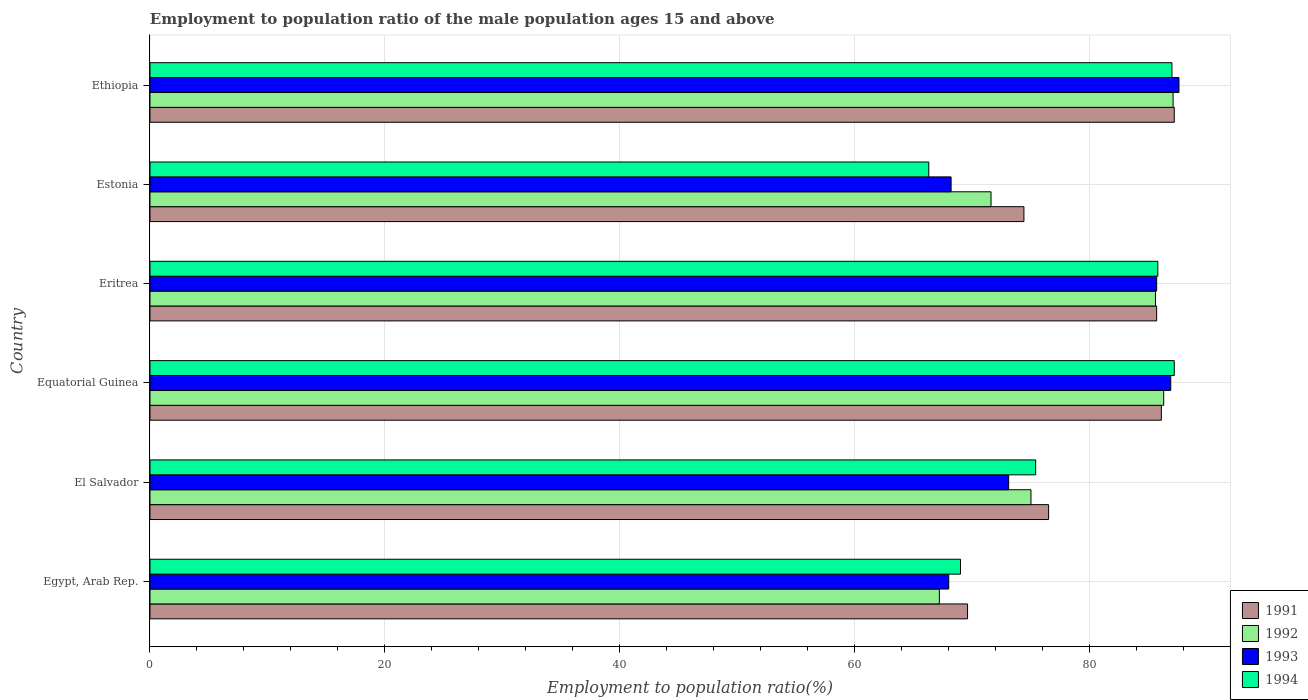How many different coloured bars are there?
Give a very brief answer. 4. How many groups of bars are there?
Your answer should be very brief. 6. Are the number of bars per tick equal to the number of legend labels?
Ensure brevity in your answer.  Yes. Are the number of bars on each tick of the Y-axis equal?
Your response must be concise. Yes. How many bars are there on the 4th tick from the top?
Provide a short and direct response. 4. What is the label of the 6th group of bars from the top?
Your answer should be compact. Egypt, Arab Rep. In how many cases, is the number of bars for a given country not equal to the number of legend labels?
Ensure brevity in your answer.  0. Across all countries, what is the maximum employment to population ratio in 1993?
Offer a terse response. 87.6. Across all countries, what is the minimum employment to population ratio in 1991?
Keep it short and to the point. 69.6. In which country was the employment to population ratio in 1992 maximum?
Provide a short and direct response. Ethiopia. In which country was the employment to population ratio in 1991 minimum?
Make the answer very short. Egypt, Arab Rep. What is the total employment to population ratio in 1994 in the graph?
Give a very brief answer. 470.7. What is the difference between the employment to population ratio in 1991 in Egypt, Arab Rep. and that in El Salvador?
Offer a terse response. -6.9. What is the difference between the employment to population ratio in 1994 in Egypt, Arab Rep. and the employment to population ratio in 1992 in El Salvador?
Your answer should be compact. -6. What is the average employment to population ratio in 1991 per country?
Keep it short and to the point. 79.92. What is the difference between the employment to population ratio in 1991 and employment to population ratio in 1992 in El Salvador?
Your response must be concise. 1.5. In how many countries, is the employment to population ratio in 1992 greater than 48 %?
Keep it short and to the point. 6. What is the ratio of the employment to population ratio in 1993 in Egypt, Arab Rep. to that in Eritrea?
Make the answer very short. 0.79. Is the difference between the employment to population ratio in 1991 in Equatorial Guinea and Estonia greater than the difference between the employment to population ratio in 1992 in Equatorial Guinea and Estonia?
Your answer should be very brief. No. What is the difference between the highest and the second highest employment to population ratio in 1992?
Make the answer very short. 0.8. What is the difference between the highest and the lowest employment to population ratio in 1992?
Provide a succinct answer. 19.9. Is the sum of the employment to population ratio in 1992 in Equatorial Guinea and Estonia greater than the maximum employment to population ratio in 1993 across all countries?
Offer a very short reply. Yes. What does the 4th bar from the bottom in El Salvador represents?
Make the answer very short. 1994. Is it the case that in every country, the sum of the employment to population ratio in 1991 and employment to population ratio in 1994 is greater than the employment to population ratio in 1993?
Give a very brief answer. Yes. Are all the bars in the graph horizontal?
Your response must be concise. Yes. What is the difference between two consecutive major ticks on the X-axis?
Offer a very short reply. 20. Does the graph contain any zero values?
Your answer should be compact. No. What is the title of the graph?
Provide a short and direct response. Employment to population ratio of the male population ages 15 and above. Does "1979" appear as one of the legend labels in the graph?
Your answer should be compact. No. What is the Employment to population ratio(%) in 1991 in Egypt, Arab Rep.?
Your answer should be very brief. 69.6. What is the Employment to population ratio(%) of 1992 in Egypt, Arab Rep.?
Your answer should be very brief. 67.2. What is the Employment to population ratio(%) of 1994 in Egypt, Arab Rep.?
Your answer should be very brief. 69. What is the Employment to population ratio(%) in 1991 in El Salvador?
Offer a terse response. 76.5. What is the Employment to population ratio(%) in 1992 in El Salvador?
Your answer should be compact. 75. What is the Employment to population ratio(%) in 1993 in El Salvador?
Provide a succinct answer. 73.1. What is the Employment to population ratio(%) of 1994 in El Salvador?
Make the answer very short. 75.4. What is the Employment to population ratio(%) of 1991 in Equatorial Guinea?
Keep it short and to the point. 86.1. What is the Employment to population ratio(%) in 1992 in Equatorial Guinea?
Your answer should be very brief. 86.3. What is the Employment to population ratio(%) of 1993 in Equatorial Guinea?
Offer a very short reply. 86.9. What is the Employment to population ratio(%) of 1994 in Equatorial Guinea?
Ensure brevity in your answer.  87.2. What is the Employment to population ratio(%) in 1991 in Eritrea?
Provide a short and direct response. 85.7. What is the Employment to population ratio(%) of 1992 in Eritrea?
Keep it short and to the point. 85.6. What is the Employment to population ratio(%) in 1993 in Eritrea?
Your answer should be compact. 85.7. What is the Employment to population ratio(%) of 1994 in Eritrea?
Offer a very short reply. 85.8. What is the Employment to population ratio(%) in 1991 in Estonia?
Ensure brevity in your answer.  74.4. What is the Employment to population ratio(%) of 1992 in Estonia?
Your response must be concise. 71.6. What is the Employment to population ratio(%) in 1993 in Estonia?
Ensure brevity in your answer.  68.2. What is the Employment to population ratio(%) of 1994 in Estonia?
Your answer should be very brief. 66.3. What is the Employment to population ratio(%) of 1991 in Ethiopia?
Your response must be concise. 87.2. What is the Employment to population ratio(%) of 1992 in Ethiopia?
Ensure brevity in your answer.  87.1. What is the Employment to population ratio(%) in 1993 in Ethiopia?
Your answer should be compact. 87.6. Across all countries, what is the maximum Employment to population ratio(%) in 1991?
Ensure brevity in your answer.  87.2. Across all countries, what is the maximum Employment to population ratio(%) in 1992?
Provide a short and direct response. 87.1. Across all countries, what is the maximum Employment to population ratio(%) in 1993?
Keep it short and to the point. 87.6. Across all countries, what is the maximum Employment to population ratio(%) in 1994?
Your answer should be very brief. 87.2. Across all countries, what is the minimum Employment to population ratio(%) in 1991?
Keep it short and to the point. 69.6. Across all countries, what is the minimum Employment to population ratio(%) of 1992?
Provide a short and direct response. 67.2. Across all countries, what is the minimum Employment to population ratio(%) in 1994?
Provide a succinct answer. 66.3. What is the total Employment to population ratio(%) of 1991 in the graph?
Ensure brevity in your answer.  479.5. What is the total Employment to population ratio(%) of 1992 in the graph?
Offer a terse response. 472.8. What is the total Employment to population ratio(%) of 1993 in the graph?
Your response must be concise. 469.5. What is the total Employment to population ratio(%) in 1994 in the graph?
Provide a short and direct response. 470.7. What is the difference between the Employment to population ratio(%) in 1991 in Egypt, Arab Rep. and that in El Salvador?
Ensure brevity in your answer.  -6.9. What is the difference between the Employment to population ratio(%) of 1992 in Egypt, Arab Rep. and that in El Salvador?
Provide a succinct answer. -7.8. What is the difference between the Employment to population ratio(%) of 1994 in Egypt, Arab Rep. and that in El Salvador?
Provide a short and direct response. -6.4. What is the difference between the Employment to population ratio(%) in 1991 in Egypt, Arab Rep. and that in Equatorial Guinea?
Ensure brevity in your answer.  -16.5. What is the difference between the Employment to population ratio(%) of 1992 in Egypt, Arab Rep. and that in Equatorial Guinea?
Your answer should be very brief. -19.1. What is the difference between the Employment to population ratio(%) in 1993 in Egypt, Arab Rep. and that in Equatorial Guinea?
Ensure brevity in your answer.  -18.9. What is the difference between the Employment to population ratio(%) in 1994 in Egypt, Arab Rep. and that in Equatorial Guinea?
Provide a short and direct response. -18.2. What is the difference between the Employment to population ratio(%) in 1991 in Egypt, Arab Rep. and that in Eritrea?
Give a very brief answer. -16.1. What is the difference between the Employment to population ratio(%) of 1992 in Egypt, Arab Rep. and that in Eritrea?
Offer a terse response. -18.4. What is the difference between the Employment to population ratio(%) of 1993 in Egypt, Arab Rep. and that in Eritrea?
Your answer should be compact. -17.7. What is the difference between the Employment to population ratio(%) of 1994 in Egypt, Arab Rep. and that in Eritrea?
Provide a succinct answer. -16.8. What is the difference between the Employment to population ratio(%) in 1991 in Egypt, Arab Rep. and that in Estonia?
Keep it short and to the point. -4.8. What is the difference between the Employment to population ratio(%) in 1992 in Egypt, Arab Rep. and that in Estonia?
Offer a very short reply. -4.4. What is the difference between the Employment to population ratio(%) of 1993 in Egypt, Arab Rep. and that in Estonia?
Offer a very short reply. -0.2. What is the difference between the Employment to population ratio(%) in 1991 in Egypt, Arab Rep. and that in Ethiopia?
Provide a short and direct response. -17.6. What is the difference between the Employment to population ratio(%) in 1992 in Egypt, Arab Rep. and that in Ethiopia?
Your answer should be compact. -19.9. What is the difference between the Employment to population ratio(%) in 1993 in Egypt, Arab Rep. and that in Ethiopia?
Your answer should be very brief. -19.6. What is the difference between the Employment to population ratio(%) of 1993 in El Salvador and that in Equatorial Guinea?
Provide a short and direct response. -13.8. What is the difference between the Employment to population ratio(%) in 1994 in El Salvador and that in Eritrea?
Offer a terse response. -10.4. What is the difference between the Employment to population ratio(%) of 1993 in El Salvador and that in Estonia?
Provide a short and direct response. 4.9. What is the difference between the Employment to population ratio(%) in 1991 in El Salvador and that in Ethiopia?
Ensure brevity in your answer.  -10.7. What is the difference between the Employment to population ratio(%) of 1992 in El Salvador and that in Ethiopia?
Your response must be concise. -12.1. What is the difference between the Employment to population ratio(%) in 1992 in Equatorial Guinea and that in Eritrea?
Offer a very short reply. 0.7. What is the difference between the Employment to population ratio(%) of 1994 in Equatorial Guinea and that in Eritrea?
Ensure brevity in your answer.  1.4. What is the difference between the Employment to population ratio(%) in 1991 in Equatorial Guinea and that in Estonia?
Give a very brief answer. 11.7. What is the difference between the Employment to population ratio(%) of 1994 in Equatorial Guinea and that in Estonia?
Make the answer very short. 20.9. What is the difference between the Employment to population ratio(%) of 1992 in Equatorial Guinea and that in Ethiopia?
Your response must be concise. -0.8. What is the difference between the Employment to population ratio(%) of 1993 in Equatorial Guinea and that in Ethiopia?
Offer a terse response. -0.7. What is the difference between the Employment to population ratio(%) of 1994 in Equatorial Guinea and that in Ethiopia?
Give a very brief answer. 0.2. What is the difference between the Employment to population ratio(%) in 1991 in Eritrea and that in Estonia?
Ensure brevity in your answer.  11.3. What is the difference between the Employment to population ratio(%) in 1994 in Eritrea and that in Estonia?
Keep it short and to the point. 19.5. What is the difference between the Employment to population ratio(%) of 1991 in Eritrea and that in Ethiopia?
Your answer should be compact. -1.5. What is the difference between the Employment to population ratio(%) of 1993 in Eritrea and that in Ethiopia?
Your answer should be very brief. -1.9. What is the difference between the Employment to population ratio(%) in 1991 in Estonia and that in Ethiopia?
Provide a short and direct response. -12.8. What is the difference between the Employment to population ratio(%) of 1992 in Estonia and that in Ethiopia?
Your answer should be very brief. -15.5. What is the difference between the Employment to population ratio(%) of 1993 in Estonia and that in Ethiopia?
Make the answer very short. -19.4. What is the difference between the Employment to population ratio(%) in 1994 in Estonia and that in Ethiopia?
Your answer should be very brief. -20.7. What is the difference between the Employment to population ratio(%) of 1991 in Egypt, Arab Rep. and the Employment to population ratio(%) of 1992 in El Salvador?
Make the answer very short. -5.4. What is the difference between the Employment to population ratio(%) of 1991 in Egypt, Arab Rep. and the Employment to population ratio(%) of 1993 in El Salvador?
Your response must be concise. -3.5. What is the difference between the Employment to population ratio(%) of 1991 in Egypt, Arab Rep. and the Employment to population ratio(%) of 1994 in El Salvador?
Provide a short and direct response. -5.8. What is the difference between the Employment to population ratio(%) in 1993 in Egypt, Arab Rep. and the Employment to population ratio(%) in 1994 in El Salvador?
Make the answer very short. -7.4. What is the difference between the Employment to population ratio(%) in 1991 in Egypt, Arab Rep. and the Employment to population ratio(%) in 1992 in Equatorial Guinea?
Offer a terse response. -16.7. What is the difference between the Employment to population ratio(%) of 1991 in Egypt, Arab Rep. and the Employment to population ratio(%) of 1993 in Equatorial Guinea?
Your answer should be compact. -17.3. What is the difference between the Employment to population ratio(%) of 1991 in Egypt, Arab Rep. and the Employment to population ratio(%) of 1994 in Equatorial Guinea?
Your response must be concise. -17.6. What is the difference between the Employment to population ratio(%) of 1992 in Egypt, Arab Rep. and the Employment to population ratio(%) of 1993 in Equatorial Guinea?
Give a very brief answer. -19.7. What is the difference between the Employment to population ratio(%) of 1992 in Egypt, Arab Rep. and the Employment to population ratio(%) of 1994 in Equatorial Guinea?
Give a very brief answer. -20. What is the difference between the Employment to population ratio(%) of 1993 in Egypt, Arab Rep. and the Employment to population ratio(%) of 1994 in Equatorial Guinea?
Offer a terse response. -19.2. What is the difference between the Employment to population ratio(%) of 1991 in Egypt, Arab Rep. and the Employment to population ratio(%) of 1992 in Eritrea?
Keep it short and to the point. -16. What is the difference between the Employment to population ratio(%) of 1991 in Egypt, Arab Rep. and the Employment to population ratio(%) of 1993 in Eritrea?
Ensure brevity in your answer.  -16.1. What is the difference between the Employment to population ratio(%) of 1991 in Egypt, Arab Rep. and the Employment to population ratio(%) of 1994 in Eritrea?
Give a very brief answer. -16.2. What is the difference between the Employment to population ratio(%) of 1992 in Egypt, Arab Rep. and the Employment to population ratio(%) of 1993 in Eritrea?
Keep it short and to the point. -18.5. What is the difference between the Employment to population ratio(%) in 1992 in Egypt, Arab Rep. and the Employment to population ratio(%) in 1994 in Eritrea?
Your answer should be compact. -18.6. What is the difference between the Employment to population ratio(%) of 1993 in Egypt, Arab Rep. and the Employment to population ratio(%) of 1994 in Eritrea?
Make the answer very short. -17.8. What is the difference between the Employment to population ratio(%) in 1991 in Egypt, Arab Rep. and the Employment to population ratio(%) in 1992 in Estonia?
Your answer should be compact. -2. What is the difference between the Employment to population ratio(%) in 1991 in Egypt, Arab Rep. and the Employment to population ratio(%) in 1993 in Estonia?
Your response must be concise. 1.4. What is the difference between the Employment to population ratio(%) of 1991 in Egypt, Arab Rep. and the Employment to population ratio(%) of 1994 in Estonia?
Provide a short and direct response. 3.3. What is the difference between the Employment to population ratio(%) in 1992 in Egypt, Arab Rep. and the Employment to population ratio(%) in 1993 in Estonia?
Provide a short and direct response. -1. What is the difference between the Employment to population ratio(%) of 1992 in Egypt, Arab Rep. and the Employment to population ratio(%) of 1994 in Estonia?
Keep it short and to the point. 0.9. What is the difference between the Employment to population ratio(%) of 1991 in Egypt, Arab Rep. and the Employment to population ratio(%) of 1992 in Ethiopia?
Offer a very short reply. -17.5. What is the difference between the Employment to population ratio(%) of 1991 in Egypt, Arab Rep. and the Employment to population ratio(%) of 1993 in Ethiopia?
Provide a succinct answer. -18. What is the difference between the Employment to population ratio(%) in 1991 in Egypt, Arab Rep. and the Employment to population ratio(%) in 1994 in Ethiopia?
Ensure brevity in your answer.  -17.4. What is the difference between the Employment to population ratio(%) in 1992 in Egypt, Arab Rep. and the Employment to population ratio(%) in 1993 in Ethiopia?
Give a very brief answer. -20.4. What is the difference between the Employment to population ratio(%) in 1992 in Egypt, Arab Rep. and the Employment to population ratio(%) in 1994 in Ethiopia?
Provide a succinct answer. -19.8. What is the difference between the Employment to population ratio(%) of 1993 in Egypt, Arab Rep. and the Employment to population ratio(%) of 1994 in Ethiopia?
Give a very brief answer. -19. What is the difference between the Employment to population ratio(%) of 1991 in El Salvador and the Employment to population ratio(%) of 1992 in Equatorial Guinea?
Offer a terse response. -9.8. What is the difference between the Employment to population ratio(%) of 1991 in El Salvador and the Employment to population ratio(%) of 1993 in Equatorial Guinea?
Your answer should be compact. -10.4. What is the difference between the Employment to population ratio(%) of 1991 in El Salvador and the Employment to population ratio(%) of 1994 in Equatorial Guinea?
Give a very brief answer. -10.7. What is the difference between the Employment to population ratio(%) in 1993 in El Salvador and the Employment to population ratio(%) in 1994 in Equatorial Guinea?
Offer a very short reply. -14.1. What is the difference between the Employment to population ratio(%) of 1991 in El Salvador and the Employment to population ratio(%) of 1992 in Eritrea?
Provide a short and direct response. -9.1. What is the difference between the Employment to population ratio(%) in 1993 in El Salvador and the Employment to population ratio(%) in 1994 in Eritrea?
Give a very brief answer. -12.7. What is the difference between the Employment to population ratio(%) of 1991 in El Salvador and the Employment to population ratio(%) of 1992 in Estonia?
Give a very brief answer. 4.9. What is the difference between the Employment to population ratio(%) in 1991 in El Salvador and the Employment to population ratio(%) in 1994 in Estonia?
Offer a terse response. 10.2. What is the difference between the Employment to population ratio(%) in 1992 in El Salvador and the Employment to population ratio(%) in 1993 in Estonia?
Ensure brevity in your answer.  6.8. What is the difference between the Employment to population ratio(%) of 1992 in El Salvador and the Employment to population ratio(%) of 1994 in Estonia?
Your response must be concise. 8.7. What is the difference between the Employment to population ratio(%) in 1993 in El Salvador and the Employment to population ratio(%) in 1994 in Estonia?
Give a very brief answer. 6.8. What is the difference between the Employment to population ratio(%) in 1991 in El Salvador and the Employment to population ratio(%) in 1992 in Ethiopia?
Offer a very short reply. -10.6. What is the difference between the Employment to population ratio(%) of 1992 in El Salvador and the Employment to population ratio(%) of 1994 in Ethiopia?
Offer a terse response. -12. What is the difference between the Employment to population ratio(%) of 1993 in El Salvador and the Employment to population ratio(%) of 1994 in Ethiopia?
Provide a succinct answer. -13.9. What is the difference between the Employment to population ratio(%) of 1991 in Equatorial Guinea and the Employment to population ratio(%) of 1992 in Eritrea?
Your answer should be compact. 0.5. What is the difference between the Employment to population ratio(%) of 1991 in Equatorial Guinea and the Employment to population ratio(%) of 1994 in Eritrea?
Give a very brief answer. 0.3. What is the difference between the Employment to population ratio(%) in 1992 in Equatorial Guinea and the Employment to population ratio(%) in 1994 in Eritrea?
Give a very brief answer. 0.5. What is the difference between the Employment to population ratio(%) in 1993 in Equatorial Guinea and the Employment to population ratio(%) in 1994 in Eritrea?
Give a very brief answer. 1.1. What is the difference between the Employment to population ratio(%) of 1991 in Equatorial Guinea and the Employment to population ratio(%) of 1994 in Estonia?
Your response must be concise. 19.8. What is the difference between the Employment to population ratio(%) in 1992 in Equatorial Guinea and the Employment to population ratio(%) in 1994 in Estonia?
Offer a terse response. 20. What is the difference between the Employment to population ratio(%) in 1993 in Equatorial Guinea and the Employment to population ratio(%) in 1994 in Estonia?
Offer a very short reply. 20.6. What is the difference between the Employment to population ratio(%) in 1991 in Equatorial Guinea and the Employment to population ratio(%) in 1992 in Ethiopia?
Make the answer very short. -1. What is the difference between the Employment to population ratio(%) of 1993 in Equatorial Guinea and the Employment to population ratio(%) of 1994 in Ethiopia?
Your response must be concise. -0.1. What is the difference between the Employment to population ratio(%) in 1991 in Eritrea and the Employment to population ratio(%) in 1992 in Estonia?
Keep it short and to the point. 14.1. What is the difference between the Employment to population ratio(%) of 1991 in Eritrea and the Employment to population ratio(%) of 1993 in Estonia?
Your answer should be very brief. 17.5. What is the difference between the Employment to population ratio(%) of 1992 in Eritrea and the Employment to population ratio(%) of 1994 in Estonia?
Offer a very short reply. 19.3. What is the difference between the Employment to population ratio(%) of 1991 in Eritrea and the Employment to population ratio(%) of 1994 in Ethiopia?
Make the answer very short. -1.3. What is the difference between the Employment to population ratio(%) in 1992 in Eritrea and the Employment to population ratio(%) in 1994 in Ethiopia?
Provide a succinct answer. -1.4. What is the difference between the Employment to population ratio(%) in 1991 in Estonia and the Employment to population ratio(%) in 1992 in Ethiopia?
Your answer should be compact. -12.7. What is the difference between the Employment to population ratio(%) in 1991 in Estonia and the Employment to population ratio(%) in 1993 in Ethiopia?
Give a very brief answer. -13.2. What is the difference between the Employment to population ratio(%) in 1991 in Estonia and the Employment to population ratio(%) in 1994 in Ethiopia?
Make the answer very short. -12.6. What is the difference between the Employment to population ratio(%) in 1992 in Estonia and the Employment to population ratio(%) in 1994 in Ethiopia?
Keep it short and to the point. -15.4. What is the difference between the Employment to population ratio(%) of 1993 in Estonia and the Employment to population ratio(%) of 1994 in Ethiopia?
Keep it short and to the point. -18.8. What is the average Employment to population ratio(%) of 1991 per country?
Your answer should be compact. 79.92. What is the average Employment to population ratio(%) of 1992 per country?
Make the answer very short. 78.8. What is the average Employment to population ratio(%) of 1993 per country?
Provide a succinct answer. 78.25. What is the average Employment to population ratio(%) in 1994 per country?
Offer a very short reply. 78.45. What is the difference between the Employment to population ratio(%) in 1992 and Employment to population ratio(%) in 1993 in Egypt, Arab Rep.?
Offer a terse response. -0.8. What is the difference between the Employment to population ratio(%) in 1992 and Employment to population ratio(%) in 1994 in Egypt, Arab Rep.?
Your answer should be very brief. -1.8. What is the difference between the Employment to population ratio(%) of 1993 and Employment to population ratio(%) of 1994 in Egypt, Arab Rep.?
Ensure brevity in your answer.  -1. What is the difference between the Employment to population ratio(%) of 1991 and Employment to population ratio(%) of 1992 in El Salvador?
Provide a succinct answer. 1.5. What is the difference between the Employment to population ratio(%) in 1992 and Employment to population ratio(%) in 1993 in El Salvador?
Provide a succinct answer. 1.9. What is the difference between the Employment to population ratio(%) in 1991 and Employment to population ratio(%) in 1992 in Equatorial Guinea?
Offer a terse response. -0.2. What is the difference between the Employment to population ratio(%) in 1991 and Employment to population ratio(%) in 1994 in Equatorial Guinea?
Your response must be concise. -1.1. What is the difference between the Employment to population ratio(%) in 1992 and Employment to population ratio(%) in 1994 in Equatorial Guinea?
Keep it short and to the point. -0.9. What is the difference between the Employment to population ratio(%) of 1993 and Employment to population ratio(%) of 1994 in Equatorial Guinea?
Keep it short and to the point. -0.3. What is the difference between the Employment to population ratio(%) of 1991 and Employment to population ratio(%) of 1994 in Eritrea?
Your answer should be compact. -0.1. What is the difference between the Employment to population ratio(%) of 1992 and Employment to population ratio(%) of 1993 in Eritrea?
Make the answer very short. -0.1. What is the difference between the Employment to population ratio(%) of 1992 and Employment to population ratio(%) of 1994 in Eritrea?
Make the answer very short. -0.2. What is the difference between the Employment to population ratio(%) of 1993 and Employment to population ratio(%) of 1994 in Eritrea?
Keep it short and to the point. -0.1. What is the difference between the Employment to population ratio(%) in 1991 and Employment to population ratio(%) in 1992 in Estonia?
Make the answer very short. 2.8. What is the difference between the Employment to population ratio(%) in 1991 and Employment to population ratio(%) in 1993 in Estonia?
Make the answer very short. 6.2. What is the difference between the Employment to population ratio(%) in 1991 and Employment to population ratio(%) in 1994 in Estonia?
Give a very brief answer. 8.1. What is the difference between the Employment to population ratio(%) in 1992 and Employment to population ratio(%) in 1994 in Estonia?
Provide a short and direct response. 5.3. What is the difference between the Employment to population ratio(%) of 1993 and Employment to population ratio(%) of 1994 in Estonia?
Provide a short and direct response. 1.9. What is the difference between the Employment to population ratio(%) of 1991 and Employment to population ratio(%) of 1994 in Ethiopia?
Provide a short and direct response. 0.2. What is the difference between the Employment to population ratio(%) in 1992 and Employment to population ratio(%) in 1993 in Ethiopia?
Ensure brevity in your answer.  -0.5. What is the difference between the Employment to population ratio(%) in 1992 and Employment to population ratio(%) in 1994 in Ethiopia?
Offer a very short reply. 0.1. What is the difference between the Employment to population ratio(%) of 1993 and Employment to population ratio(%) of 1994 in Ethiopia?
Offer a terse response. 0.6. What is the ratio of the Employment to population ratio(%) in 1991 in Egypt, Arab Rep. to that in El Salvador?
Give a very brief answer. 0.91. What is the ratio of the Employment to population ratio(%) of 1992 in Egypt, Arab Rep. to that in El Salvador?
Keep it short and to the point. 0.9. What is the ratio of the Employment to population ratio(%) of 1993 in Egypt, Arab Rep. to that in El Salvador?
Your response must be concise. 0.93. What is the ratio of the Employment to population ratio(%) in 1994 in Egypt, Arab Rep. to that in El Salvador?
Offer a terse response. 0.92. What is the ratio of the Employment to population ratio(%) of 1991 in Egypt, Arab Rep. to that in Equatorial Guinea?
Offer a very short reply. 0.81. What is the ratio of the Employment to population ratio(%) in 1992 in Egypt, Arab Rep. to that in Equatorial Guinea?
Your answer should be compact. 0.78. What is the ratio of the Employment to population ratio(%) in 1993 in Egypt, Arab Rep. to that in Equatorial Guinea?
Keep it short and to the point. 0.78. What is the ratio of the Employment to population ratio(%) in 1994 in Egypt, Arab Rep. to that in Equatorial Guinea?
Give a very brief answer. 0.79. What is the ratio of the Employment to population ratio(%) of 1991 in Egypt, Arab Rep. to that in Eritrea?
Keep it short and to the point. 0.81. What is the ratio of the Employment to population ratio(%) in 1992 in Egypt, Arab Rep. to that in Eritrea?
Offer a very short reply. 0.79. What is the ratio of the Employment to population ratio(%) in 1993 in Egypt, Arab Rep. to that in Eritrea?
Ensure brevity in your answer.  0.79. What is the ratio of the Employment to population ratio(%) of 1994 in Egypt, Arab Rep. to that in Eritrea?
Your response must be concise. 0.8. What is the ratio of the Employment to population ratio(%) of 1991 in Egypt, Arab Rep. to that in Estonia?
Give a very brief answer. 0.94. What is the ratio of the Employment to population ratio(%) of 1992 in Egypt, Arab Rep. to that in Estonia?
Keep it short and to the point. 0.94. What is the ratio of the Employment to population ratio(%) in 1993 in Egypt, Arab Rep. to that in Estonia?
Offer a terse response. 1. What is the ratio of the Employment to population ratio(%) in 1994 in Egypt, Arab Rep. to that in Estonia?
Provide a succinct answer. 1.04. What is the ratio of the Employment to population ratio(%) in 1991 in Egypt, Arab Rep. to that in Ethiopia?
Make the answer very short. 0.8. What is the ratio of the Employment to population ratio(%) in 1992 in Egypt, Arab Rep. to that in Ethiopia?
Give a very brief answer. 0.77. What is the ratio of the Employment to population ratio(%) in 1993 in Egypt, Arab Rep. to that in Ethiopia?
Offer a very short reply. 0.78. What is the ratio of the Employment to population ratio(%) in 1994 in Egypt, Arab Rep. to that in Ethiopia?
Give a very brief answer. 0.79. What is the ratio of the Employment to population ratio(%) of 1991 in El Salvador to that in Equatorial Guinea?
Your response must be concise. 0.89. What is the ratio of the Employment to population ratio(%) of 1992 in El Salvador to that in Equatorial Guinea?
Keep it short and to the point. 0.87. What is the ratio of the Employment to population ratio(%) of 1993 in El Salvador to that in Equatorial Guinea?
Your answer should be very brief. 0.84. What is the ratio of the Employment to population ratio(%) of 1994 in El Salvador to that in Equatorial Guinea?
Provide a short and direct response. 0.86. What is the ratio of the Employment to population ratio(%) in 1991 in El Salvador to that in Eritrea?
Make the answer very short. 0.89. What is the ratio of the Employment to population ratio(%) in 1992 in El Salvador to that in Eritrea?
Ensure brevity in your answer.  0.88. What is the ratio of the Employment to population ratio(%) in 1993 in El Salvador to that in Eritrea?
Provide a short and direct response. 0.85. What is the ratio of the Employment to population ratio(%) of 1994 in El Salvador to that in Eritrea?
Your answer should be very brief. 0.88. What is the ratio of the Employment to population ratio(%) of 1991 in El Salvador to that in Estonia?
Offer a terse response. 1.03. What is the ratio of the Employment to population ratio(%) of 1992 in El Salvador to that in Estonia?
Your answer should be compact. 1.05. What is the ratio of the Employment to population ratio(%) of 1993 in El Salvador to that in Estonia?
Give a very brief answer. 1.07. What is the ratio of the Employment to population ratio(%) of 1994 in El Salvador to that in Estonia?
Ensure brevity in your answer.  1.14. What is the ratio of the Employment to population ratio(%) in 1991 in El Salvador to that in Ethiopia?
Offer a very short reply. 0.88. What is the ratio of the Employment to population ratio(%) in 1992 in El Salvador to that in Ethiopia?
Provide a short and direct response. 0.86. What is the ratio of the Employment to population ratio(%) in 1993 in El Salvador to that in Ethiopia?
Offer a very short reply. 0.83. What is the ratio of the Employment to population ratio(%) in 1994 in El Salvador to that in Ethiopia?
Provide a succinct answer. 0.87. What is the ratio of the Employment to population ratio(%) of 1992 in Equatorial Guinea to that in Eritrea?
Provide a short and direct response. 1.01. What is the ratio of the Employment to population ratio(%) of 1993 in Equatorial Guinea to that in Eritrea?
Make the answer very short. 1.01. What is the ratio of the Employment to population ratio(%) in 1994 in Equatorial Guinea to that in Eritrea?
Your answer should be compact. 1.02. What is the ratio of the Employment to population ratio(%) in 1991 in Equatorial Guinea to that in Estonia?
Your answer should be very brief. 1.16. What is the ratio of the Employment to population ratio(%) of 1992 in Equatorial Guinea to that in Estonia?
Provide a short and direct response. 1.21. What is the ratio of the Employment to population ratio(%) of 1993 in Equatorial Guinea to that in Estonia?
Offer a terse response. 1.27. What is the ratio of the Employment to population ratio(%) in 1994 in Equatorial Guinea to that in Estonia?
Your answer should be very brief. 1.32. What is the ratio of the Employment to population ratio(%) in 1991 in Equatorial Guinea to that in Ethiopia?
Make the answer very short. 0.99. What is the ratio of the Employment to population ratio(%) in 1992 in Equatorial Guinea to that in Ethiopia?
Your response must be concise. 0.99. What is the ratio of the Employment to population ratio(%) in 1993 in Equatorial Guinea to that in Ethiopia?
Provide a short and direct response. 0.99. What is the ratio of the Employment to population ratio(%) of 1991 in Eritrea to that in Estonia?
Your response must be concise. 1.15. What is the ratio of the Employment to population ratio(%) in 1992 in Eritrea to that in Estonia?
Your answer should be very brief. 1.2. What is the ratio of the Employment to population ratio(%) in 1993 in Eritrea to that in Estonia?
Keep it short and to the point. 1.26. What is the ratio of the Employment to population ratio(%) of 1994 in Eritrea to that in Estonia?
Your answer should be very brief. 1.29. What is the ratio of the Employment to population ratio(%) of 1991 in Eritrea to that in Ethiopia?
Offer a very short reply. 0.98. What is the ratio of the Employment to population ratio(%) of 1992 in Eritrea to that in Ethiopia?
Make the answer very short. 0.98. What is the ratio of the Employment to population ratio(%) of 1993 in Eritrea to that in Ethiopia?
Your answer should be compact. 0.98. What is the ratio of the Employment to population ratio(%) in 1994 in Eritrea to that in Ethiopia?
Give a very brief answer. 0.99. What is the ratio of the Employment to population ratio(%) of 1991 in Estonia to that in Ethiopia?
Your response must be concise. 0.85. What is the ratio of the Employment to population ratio(%) in 1992 in Estonia to that in Ethiopia?
Make the answer very short. 0.82. What is the ratio of the Employment to population ratio(%) in 1993 in Estonia to that in Ethiopia?
Offer a very short reply. 0.78. What is the ratio of the Employment to population ratio(%) in 1994 in Estonia to that in Ethiopia?
Your answer should be compact. 0.76. What is the difference between the highest and the second highest Employment to population ratio(%) of 1992?
Offer a very short reply. 0.8. What is the difference between the highest and the lowest Employment to population ratio(%) of 1991?
Make the answer very short. 17.6. What is the difference between the highest and the lowest Employment to population ratio(%) in 1993?
Your answer should be compact. 19.6. What is the difference between the highest and the lowest Employment to population ratio(%) in 1994?
Provide a short and direct response. 20.9. 